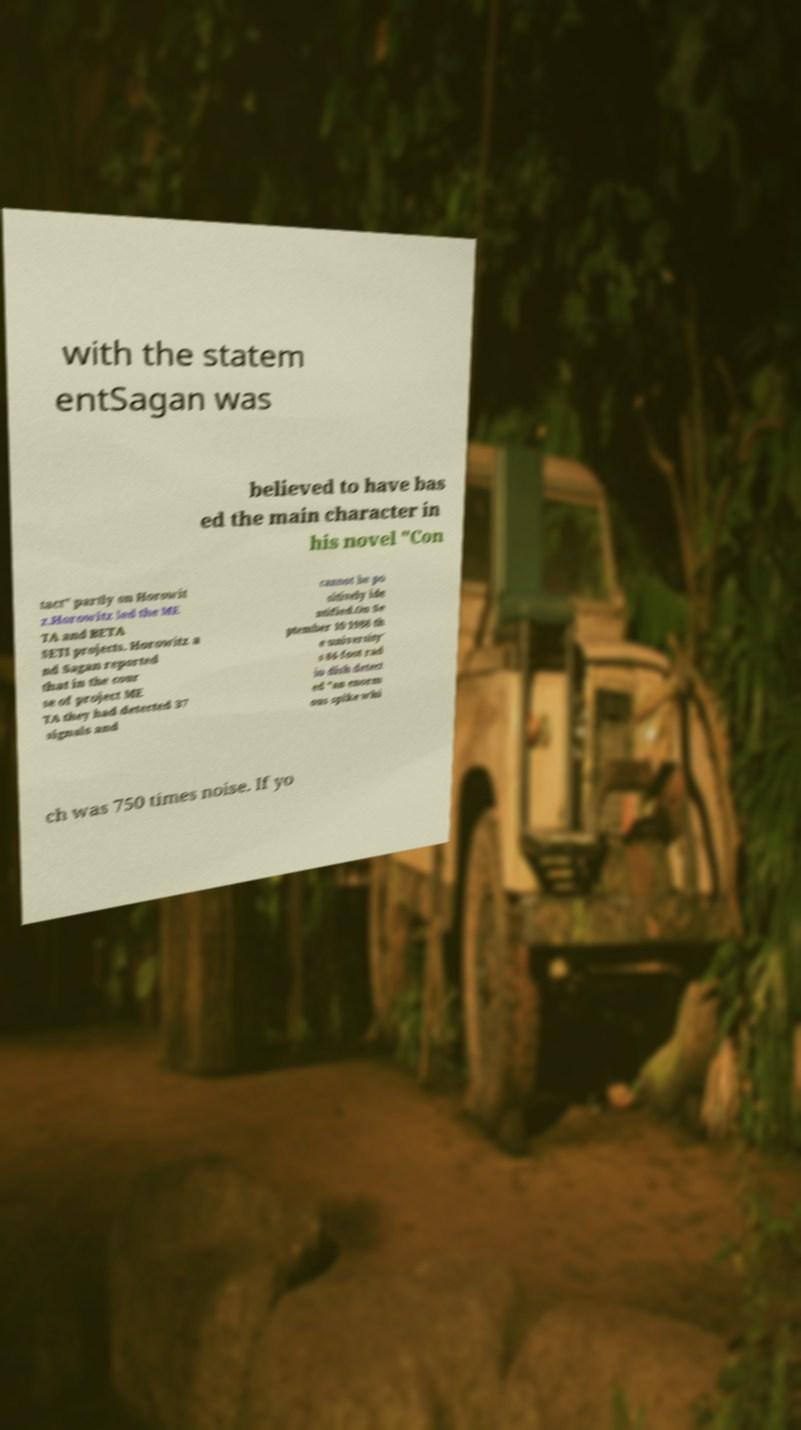Can you accurately transcribe the text from the provided image for me? with the statem entSagan was believed to have bas ed the main character in his novel "Con tact" partly on Horowit z.Horowitz led the ME TA and BETA SETI projects. Horowitz a nd Sagan reported that in the cour se of project ME TA they had detected 37 signals and cannot be po sitively ide ntified.On Se ptember 10 1988 th e university' s 84-foot rad io dish detect ed "an enorm ous spike whi ch was 750 times noise. If yo 